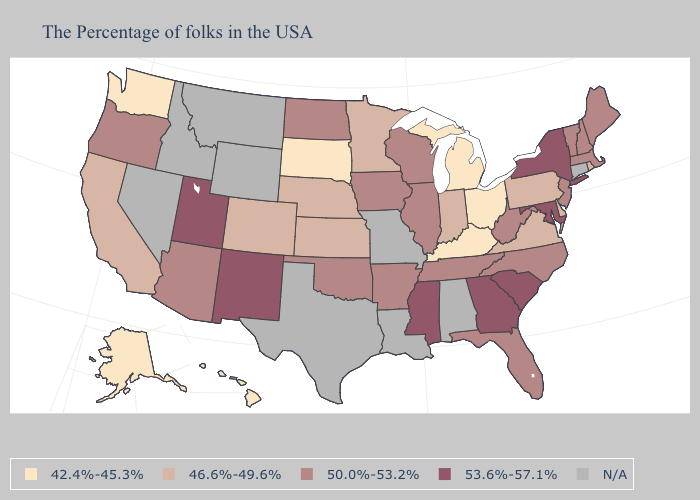Does the map have missing data?
Concise answer only. Yes. What is the highest value in states that border Utah?
Give a very brief answer. 53.6%-57.1%. Does the map have missing data?
Concise answer only. Yes. What is the value of California?
Give a very brief answer. 46.6%-49.6%. What is the value of Kentucky?
Concise answer only. 42.4%-45.3%. Name the states that have a value in the range 42.4%-45.3%?
Give a very brief answer. Ohio, Michigan, Kentucky, South Dakota, Washington, Alaska, Hawaii. Is the legend a continuous bar?
Concise answer only. No. What is the value of Virginia?
Write a very short answer. 46.6%-49.6%. What is the value of Ohio?
Quick response, please. 42.4%-45.3%. Does Indiana have the lowest value in the MidWest?
Be succinct. No. What is the lowest value in the Northeast?
Quick response, please. 46.6%-49.6%. Does New Mexico have the highest value in the West?
Be succinct. Yes. 